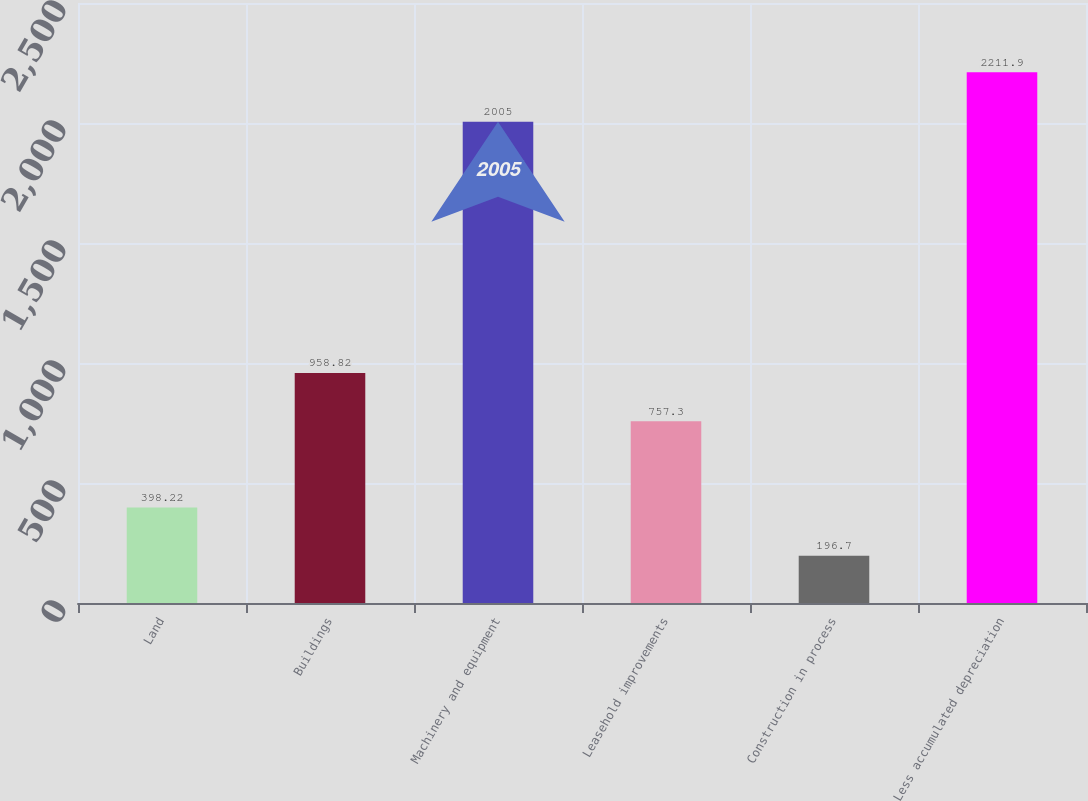Convert chart to OTSL. <chart><loc_0><loc_0><loc_500><loc_500><bar_chart><fcel>Land<fcel>Buildings<fcel>Machinery and equipment<fcel>Leasehold improvements<fcel>Construction in process<fcel>Less accumulated depreciation<nl><fcel>398.22<fcel>958.82<fcel>2005<fcel>757.3<fcel>196.7<fcel>2211.9<nl></chart> 